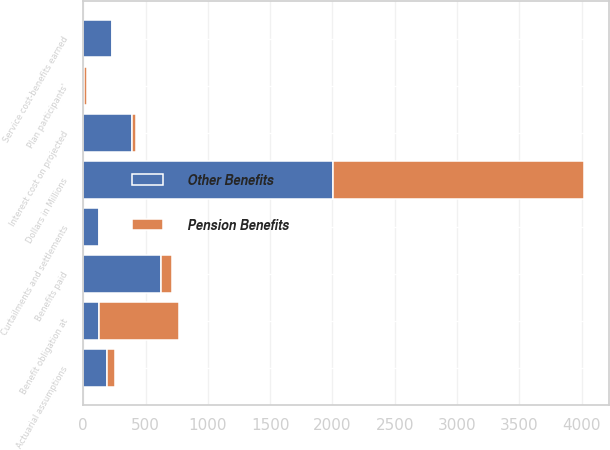Convert chart. <chart><loc_0><loc_0><loc_500><loc_500><stacked_bar_chart><ecel><fcel>Dollars in Millions<fcel>Benefit obligation at<fcel>Service cost-benefits earned<fcel>Interest cost on projected<fcel>Plan participants'<fcel>Curtailments and settlements<fcel>Actuarial assumptions<fcel>Benefits paid<nl><fcel>Other Benefits<fcel>2008<fcel>124<fcel>227<fcel>389<fcel>5<fcel>124<fcel>189<fcel>622<nl><fcel>Pension Benefits<fcel>2008<fcel>646<fcel>8<fcel>38<fcel>22<fcel>3<fcel>62<fcel>87<nl></chart> 